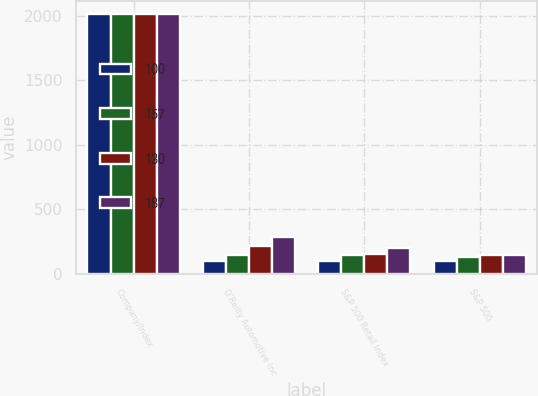<chart> <loc_0><loc_0><loc_500><loc_500><stacked_bar_chart><ecel><fcel>Company/Index<fcel>O'Reilly Automotive Inc<fcel>S&P 500 Retail Index<fcel>S&P 500<nl><fcel>100<fcel>2012<fcel>100<fcel>100<fcel>100<nl><fcel>157<fcel>2013<fcel>144<fcel>144<fcel>130<nl><fcel>130<fcel>2014<fcel>215<fcel>158<fcel>144<nl><fcel>187<fcel>2015<fcel>283<fcel>197<fcel>143<nl></chart> 